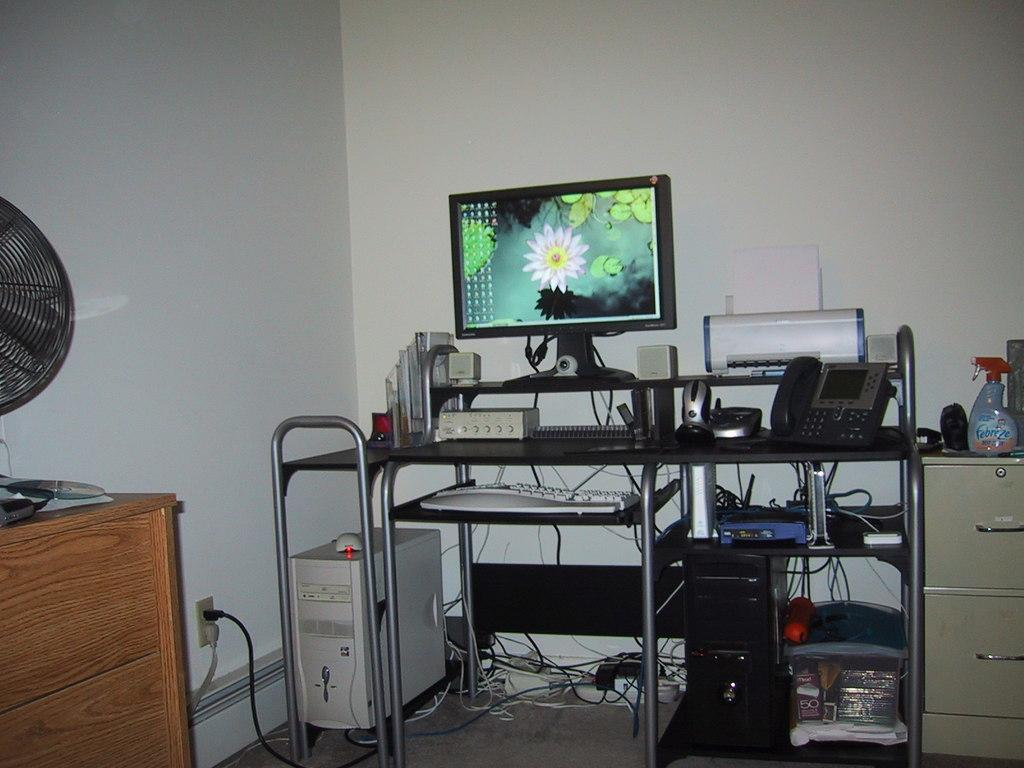What type of electronic device is visible on the desktop in the image? There is a webcam in the image. What other devices are present on the desktop? There are speakers, a mouse, a telephone, a printer, and a keyboard in the image. What is the main piece of furniture in the image? There is a desktop on a table in the image. Are there any other tables in the image? Yes, there are other tables beside and in front of the main table. What type of curtain can be seen hanging from the dock in the image? There is no dock or curtain present in the image. 